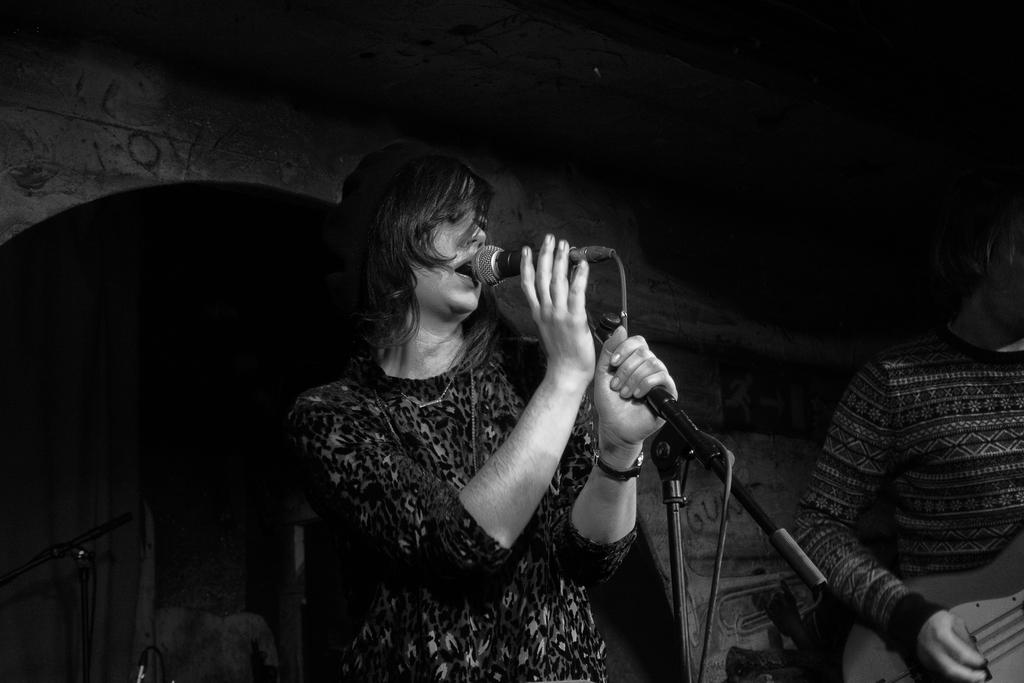How many people are in the image? There are two people in the image. Can you describe the gender of each person? One person is a woman, and the other person is a man. What is the woman holding in the image? The woman is holding a mic. What is the woman doing in the image? The woman is singing. Can you describe any accessory the woman is wearing? The woman is wearing a watch. How is the backside of the stage depicted in the image? The backside of the stage is completely dark. Are there any visible chin hairs on the woman in the image? There is no information about the woman's chin hairs in the image, so it cannot be determined. Can you see any cobwebs hanging from the ceiling in the image? There is no mention of a ceiling or cobwebs in the image, so it cannot be determined. 